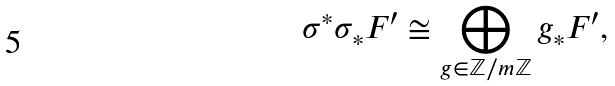Convert formula to latex. <formula><loc_0><loc_0><loc_500><loc_500>\sigma ^ { \ast } \sigma _ { \ast } F ^ { \prime } \cong \bigoplus _ { g \in \mathbb { Z } / m \mathbb { Z } } g _ { \ast } F ^ { \prime } ,</formula> 